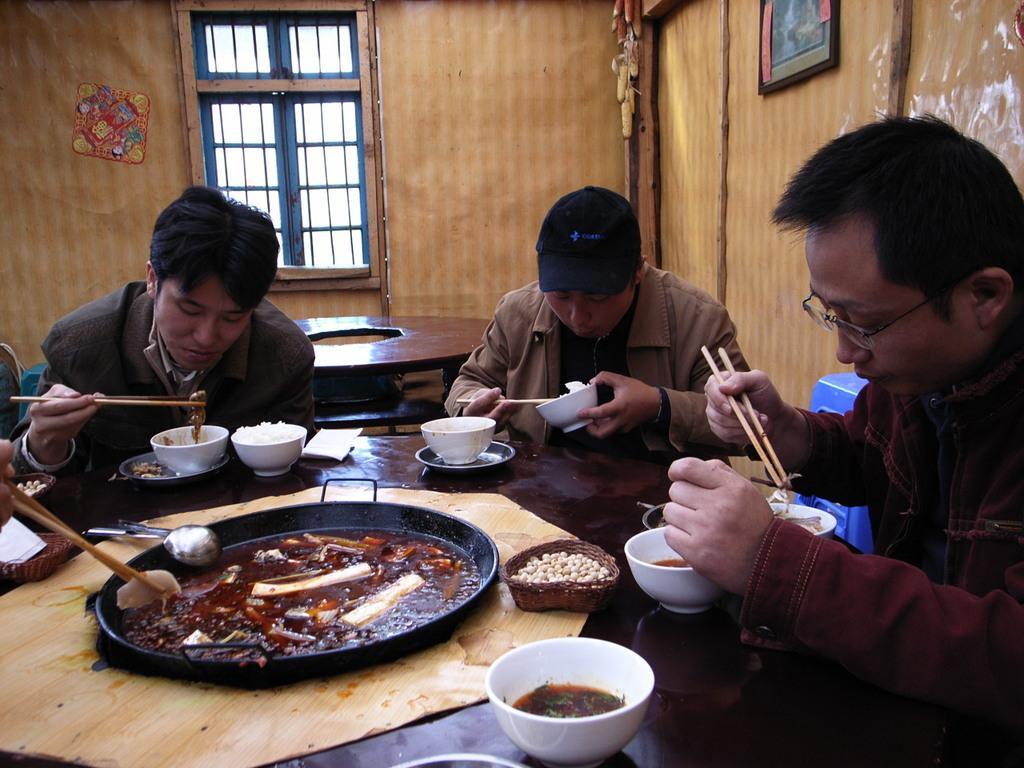In one or two sentences, can you explain what this image depicts? At the bottom of the image there is a table, on the table there are some bowls and plates and spoons and cups. Surrounding the table few people are sitting and holding some chopsticks. Behind them there is table and wall, on the wall there is a window and frame. 